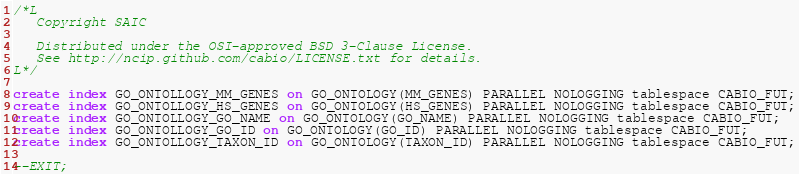<code> <loc_0><loc_0><loc_500><loc_500><_SQL_>/*L
   Copyright SAIC

   Distributed under the OSI-approved BSD 3-Clause License.
   See http://ncip.github.com/cabio/LICENSE.txt for details.
L*/

create index GO_ONTOLLOGY_MM_GENES on GO_ONTOLOGY(MM_GENES) PARALLEL NOLOGGING tablespace CABIO_FUT;
create index GO_ONTOLLOGY_HS_GENES on GO_ONTOLOGY(HS_GENES) PARALLEL NOLOGGING tablespace CABIO_FUT;
create index GO_ONTOLLOGY_GO_NAME on GO_ONTOLOGY(GO_NAME) PARALLEL NOLOGGING tablespace CABIO_FUT;
create index GO_ONTOLLOGY_GO_ID on GO_ONTOLOGY(GO_ID) PARALLEL NOLOGGING tablespace CABIO_FUT;
create index GO_ONTOLLOGY_TAXON_ID on GO_ONTOLOGY(TAXON_ID) PARALLEL NOLOGGING tablespace CABIO_FUT;

--EXIT;
</code> 